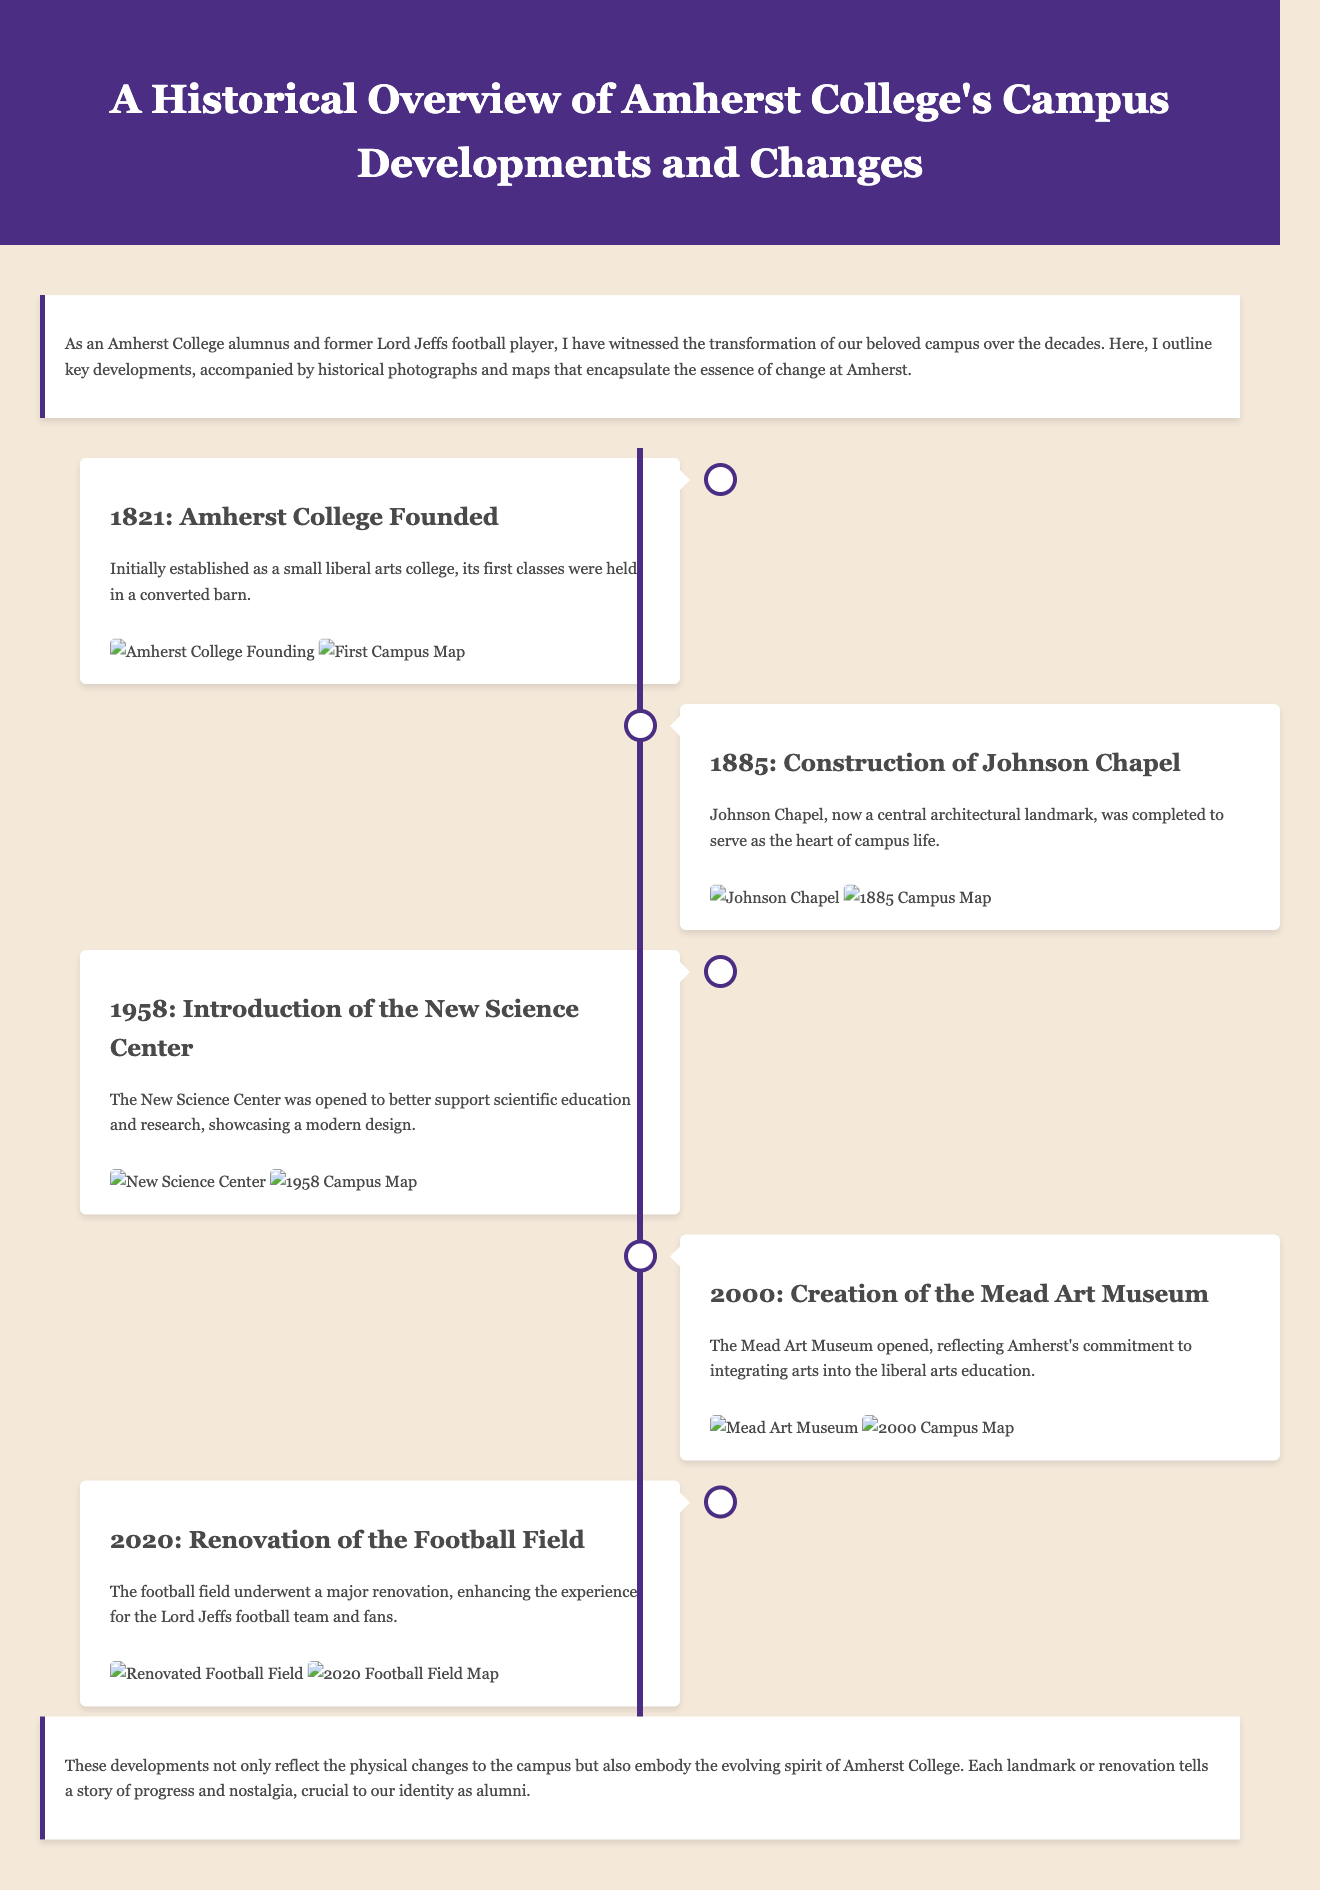What year was Amherst College founded? The document states that Amherst College was founded in 1821, which is noted as the first event in the timeline.
Answer: 1821 What significant building was completed in 1885? According to the timeline, Johnson Chapel was completed in 1885 and is a landmark of campus life.
Answer: Johnson Chapel When did the New Science Center open? The timeline mentions that the New Science Center was introduced in 1958.
Answer: 1958 What year did the Mead Art Museum open? The document specifies that the Mead Art Museum was created in 2000, which is clearly marked in the timeline.
Answer: 2000 What event occurred in 2020? The timeline indicates that the football field underwent renovation in 2020, which is the last event mentioned.
Answer: Renovation of the Football Field Which building serves as the heart of campus life? The document refers to Johnson Chapel as the heart of campus life, indicating its central importance.
Answer: Johnson Chapel How many events are listed in the timeline? By counting the events presented in the timeline, there are five key events detailed in the document.
Answer: Five What do the developments represent according to the conclusion? The conclusion states that the developments embody the evolving spirit of Amherst College.
Answer: Evolving spirit of Amherst College What type of document is this? The structure and content indicate that this is a historical overview report of campus developments at Amherst College.
Answer: Historical overview report 